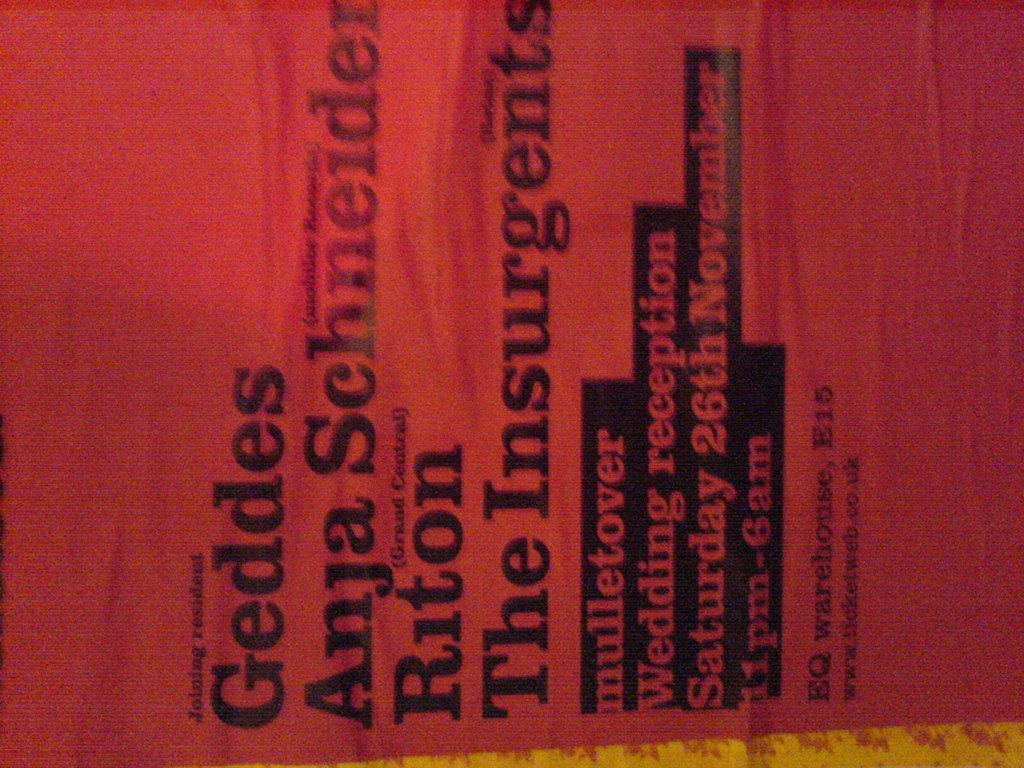<image>
Share a concise interpretation of the image provided. A red cover from a magazine that says Geddes Anja Schneider Riton The Insurgents. 